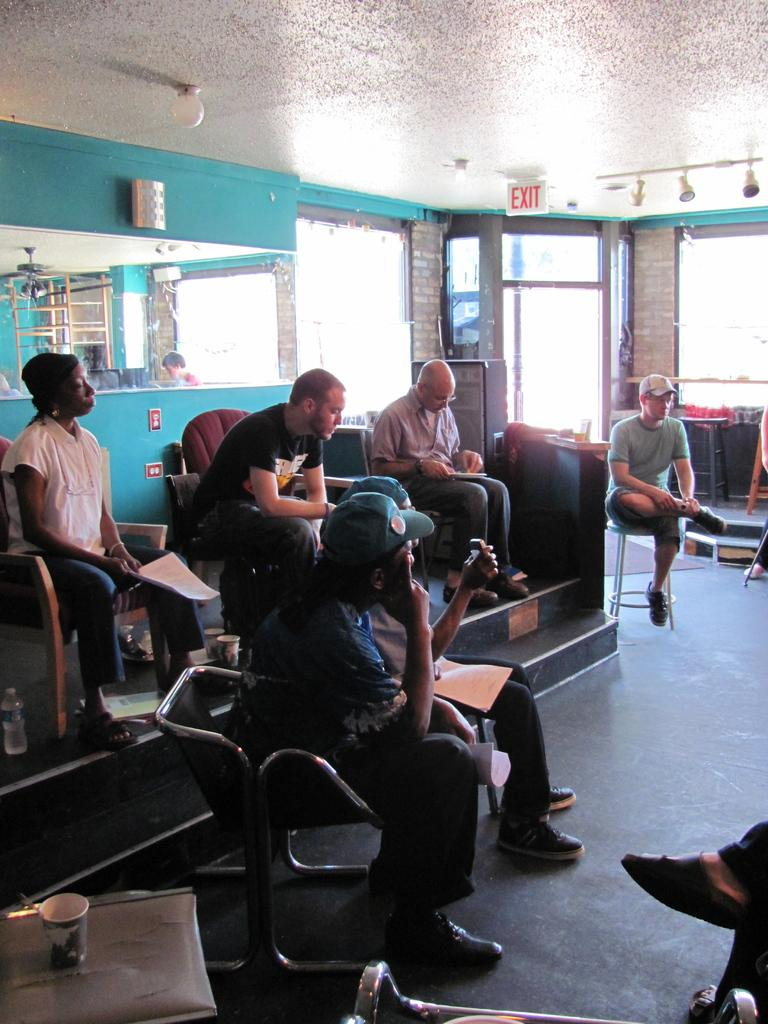What are the people in the image doing? The people in the image are sitting on chairs. Can you describe the clothing of one of the people? One person is wearing a cap. What can be seen in the background of the image? There are lights visible in the background of the image. What type of creature is sitting on the back of the chair in the image? There is no creature sitting on the back of the chair in the image; only people are present. 